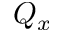<formula> <loc_0><loc_0><loc_500><loc_500>Q _ { x }</formula> 